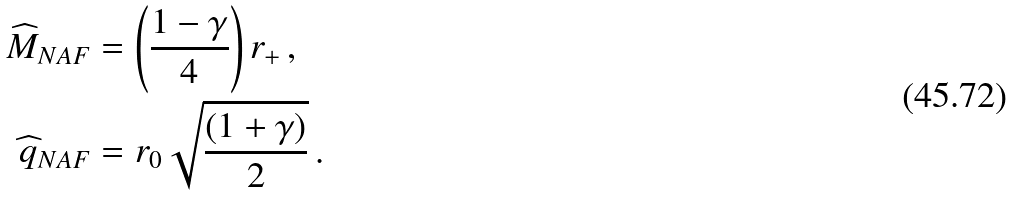Convert formula to latex. <formula><loc_0><loc_0><loc_500><loc_500>\widehat { M } _ { N A F } & = \left ( \frac { 1 - \gamma } { 4 } \right ) r _ { + } \, , \\ \widehat { q } _ { N A F } & = r _ { 0 } \sqrt { \frac { \left ( 1 + \gamma \right ) } { 2 } } \, .</formula> 